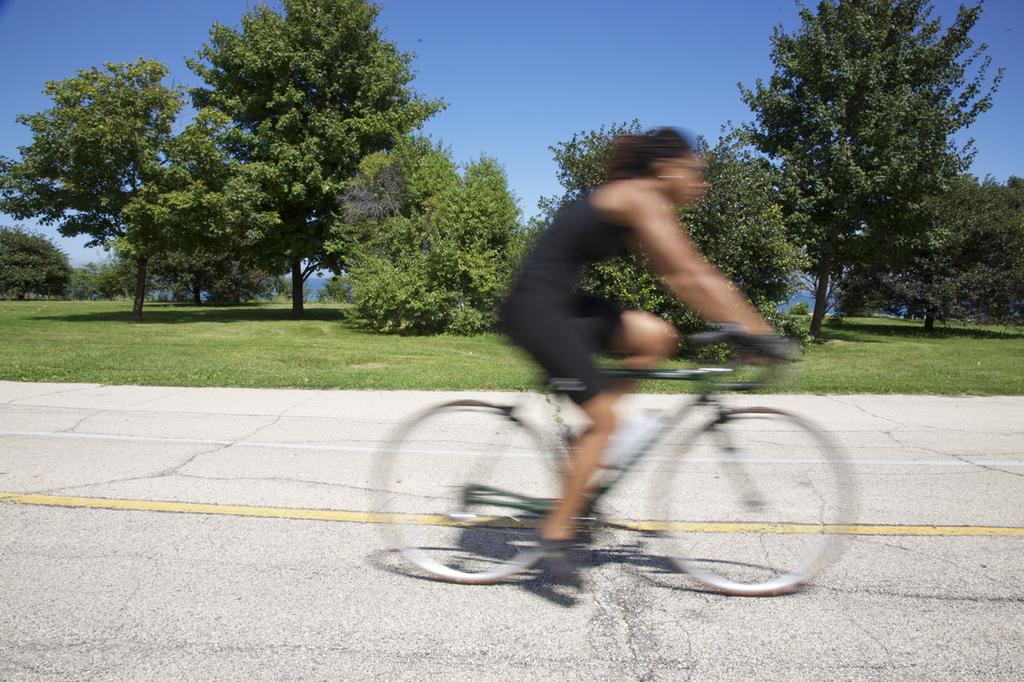What is the person in the image doing? The person is riding a bicycle in the image. Where is the bicycle located? The bicycle is on a road in the image. What can be seen in the background of the image? There is grass and trees visible in the background of the image. What type of bean is growing on the side of the road in the image? There is no bean plant visible in the image; the background features grass and trees. 